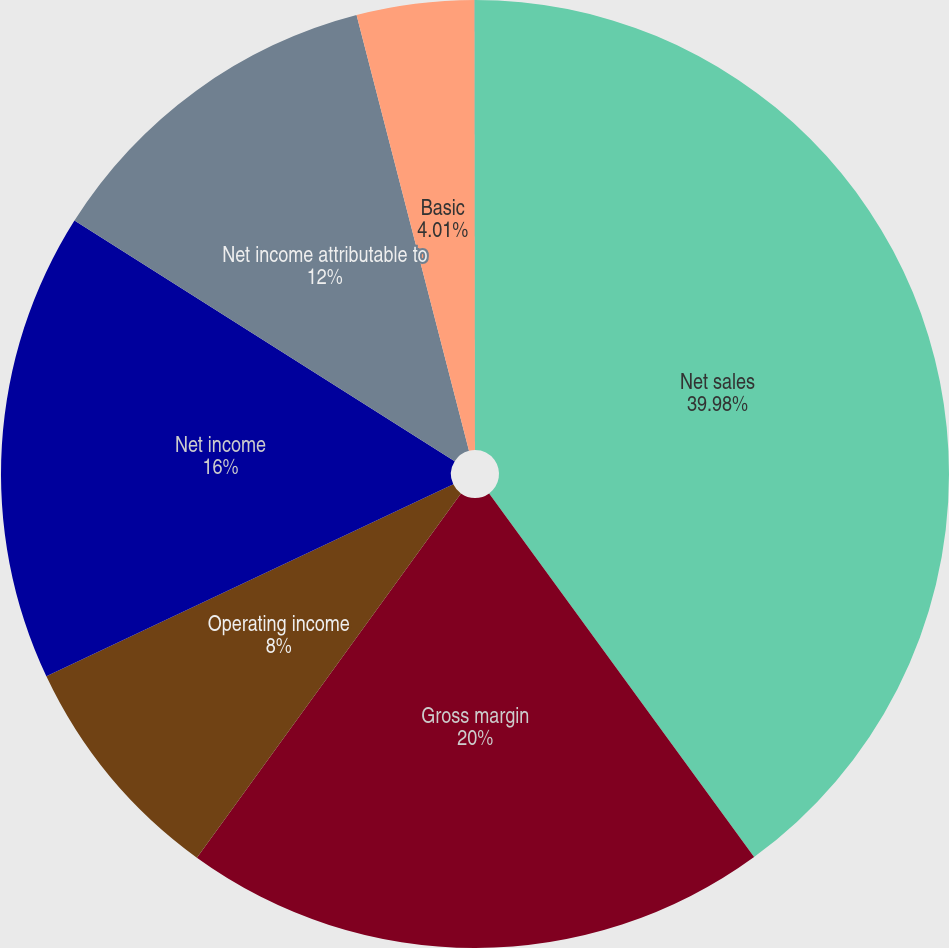<chart> <loc_0><loc_0><loc_500><loc_500><pie_chart><fcel>Net sales<fcel>Gross margin<fcel>Operating income<fcel>Net income<fcel>Net income attributable to<fcel>Basic<fcel>Diluted<nl><fcel>39.98%<fcel>20.0%<fcel>8.0%<fcel>16.0%<fcel>12.0%<fcel>4.01%<fcel>0.01%<nl></chart> 